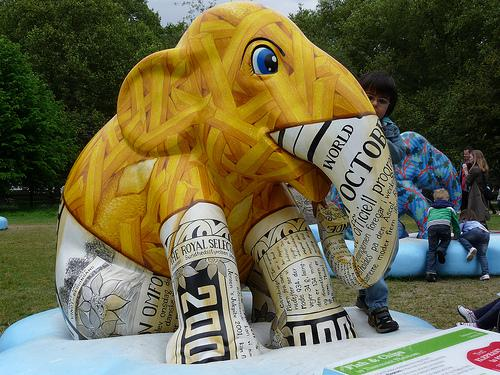Question: what color are the trees?
Choices:
A. Red.
B. Brown.
C. Green.
D. Orange.
Answer with the letter. Answer: C Question: why are the people standing in the background?
Choices:
A. To keep out of the way.
B. They are looking at another animal.
C. To watch from a distance.
D. To not disturb the animals.
Answer with the letter. Answer: B Question: where does this picture take place?
Choices:
A. The woods.
B. Park.
C. On a grassy field.
D. Zoo.
Answer with the letter. Answer: C Question: who is standing behind the elephant?
Choices:
A. Trainer.
B. Zoo keeper.
C. A boy.
D. Woman.
Answer with the letter. Answer: C 